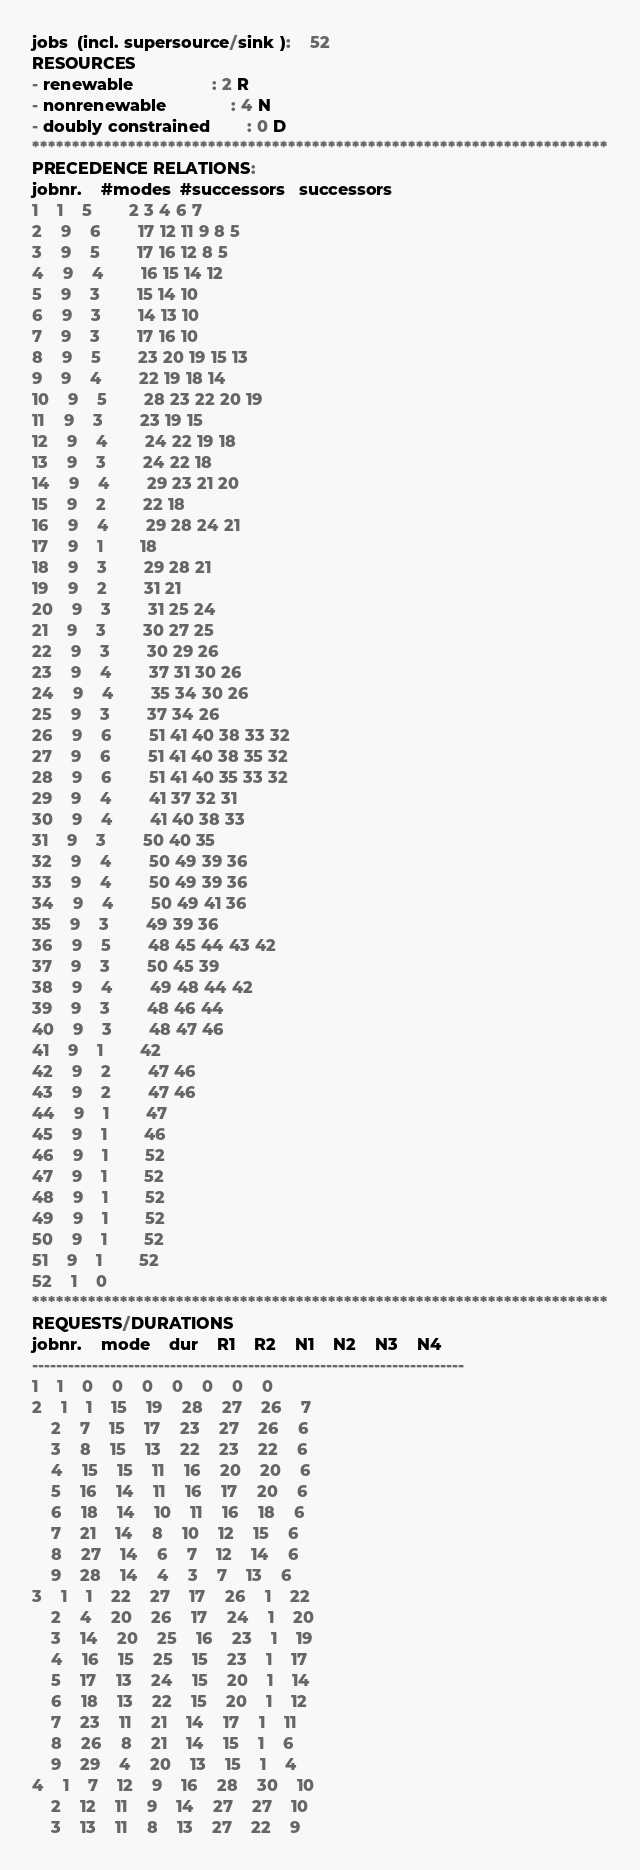<code> <loc_0><loc_0><loc_500><loc_500><_ObjectiveC_>jobs  (incl. supersource/sink ):	52
RESOURCES
- renewable                 : 2 R
- nonrenewable              : 4 N
- doubly constrained        : 0 D
************************************************************************
PRECEDENCE RELATIONS:
jobnr.    #modes  #successors   successors
1	1	5		2 3 4 6 7 
2	9	6		17 12 11 9 8 5 
3	9	5		17 16 12 8 5 
4	9	4		16 15 14 12 
5	9	3		15 14 10 
6	9	3		14 13 10 
7	9	3		17 16 10 
8	9	5		23 20 19 15 13 
9	9	4		22 19 18 14 
10	9	5		28 23 22 20 19 
11	9	3		23 19 15 
12	9	4		24 22 19 18 
13	9	3		24 22 18 
14	9	4		29 23 21 20 
15	9	2		22 18 
16	9	4		29 28 24 21 
17	9	1		18 
18	9	3		29 28 21 
19	9	2		31 21 
20	9	3		31 25 24 
21	9	3		30 27 25 
22	9	3		30 29 26 
23	9	4		37 31 30 26 
24	9	4		35 34 30 26 
25	9	3		37 34 26 
26	9	6		51 41 40 38 33 32 
27	9	6		51 41 40 38 35 32 
28	9	6		51 41 40 35 33 32 
29	9	4		41 37 32 31 
30	9	4		41 40 38 33 
31	9	3		50 40 35 
32	9	4		50 49 39 36 
33	9	4		50 49 39 36 
34	9	4		50 49 41 36 
35	9	3		49 39 36 
36	9	5		48 45 44 43 42 
37	9	3		50 45 39 
38	9	4		49 48 44 42 
39	9	3		48 46 44 
40	9	3		48 47 46 
41	9	1		42 
42	9	2		47 46 
43	9	2		47 46 
44	9	1		47 
45	9	1		46 
46	9	1		52 
47	9	1		52 
48	9	1		52 
49	9	1		52 
50	9	1		52 
51	9	1		52 
52	1	0		
************************************************************************
REQUESTS/DURATIONS
jobnr.	mode	dur	R1	R2	N1	N2	N3	N4	
------------------------------------------------------------------------
1	1	0	0	0	0	0	0	0	
2	1	1	15	19	28	27	26	7	
	2	7	15	17	23	27	26	6	
	3	8	15	13	22	23	22	6	
	4	15	15	11	16	20	20	6	
	5	16	14	11	16	17	20	6	
	6	18	14	10	11	16	18	6	
	7	21	14	8	10	12	15	6	
	8	27	14	6	7	12	14	6	
	9	28	14	4	3	7	13	6	
3	1	1	22	27	17	26	1	22	
	2	4	20	26	17	24	1	20	
	3	14	20	25	16	23	1	19	
	4	16	15	25	15	23	1	17	
	5	17	13	24	15	20	1	14	
	6	18	13	22	15	20	1	12	
	7	23	11	21	14	17	1	11	
	8	26	8	21	14	15	1	6	
	9	29	4	20	13	15	1	4	
4	1	7	12	9	16	28	30	10	
	2	12	11	9	14	27	27	10	
	3	13	11	8	13	27	22	9	</code> 